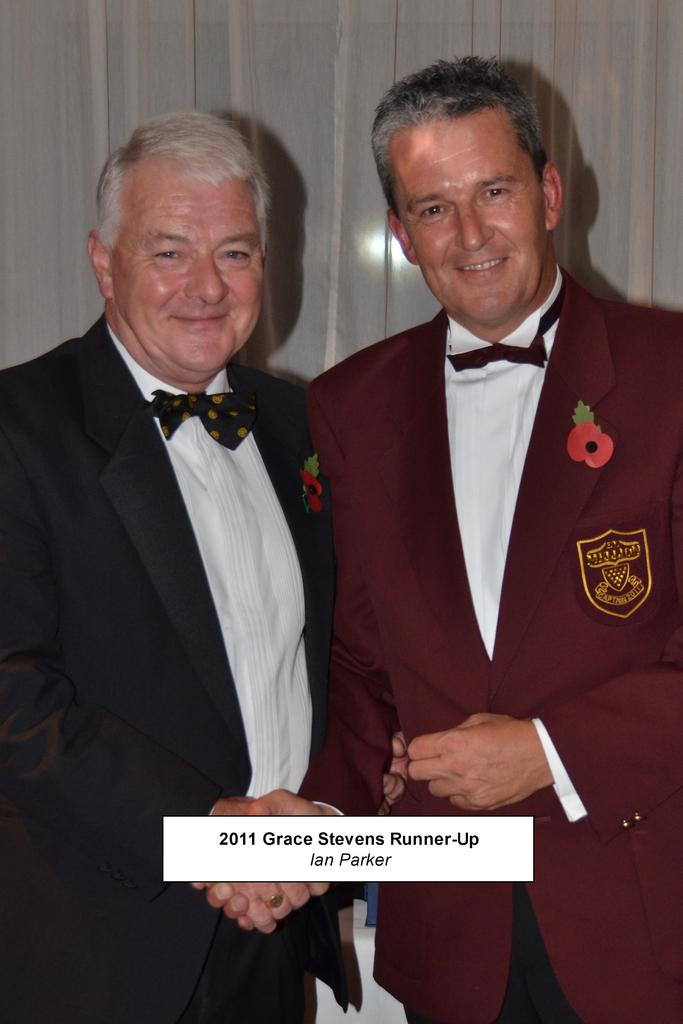How many people are in the image? There are two men in the middle of the image. What are the men doing in the image? The men are shaking hands with each other. What can be seen in the background of the image? There is a curtain in the background of the image. What is present at the bottom of the image? There is some script at the bottom of the image. What type of journey is the man on the left taking in the image? There is no indication of a journey in the image; the men are simply shaking hands. What detail can be seen on the curtain in the background? The provided facts do not mention any specific details on the curtain, so we cannot answer this question. 